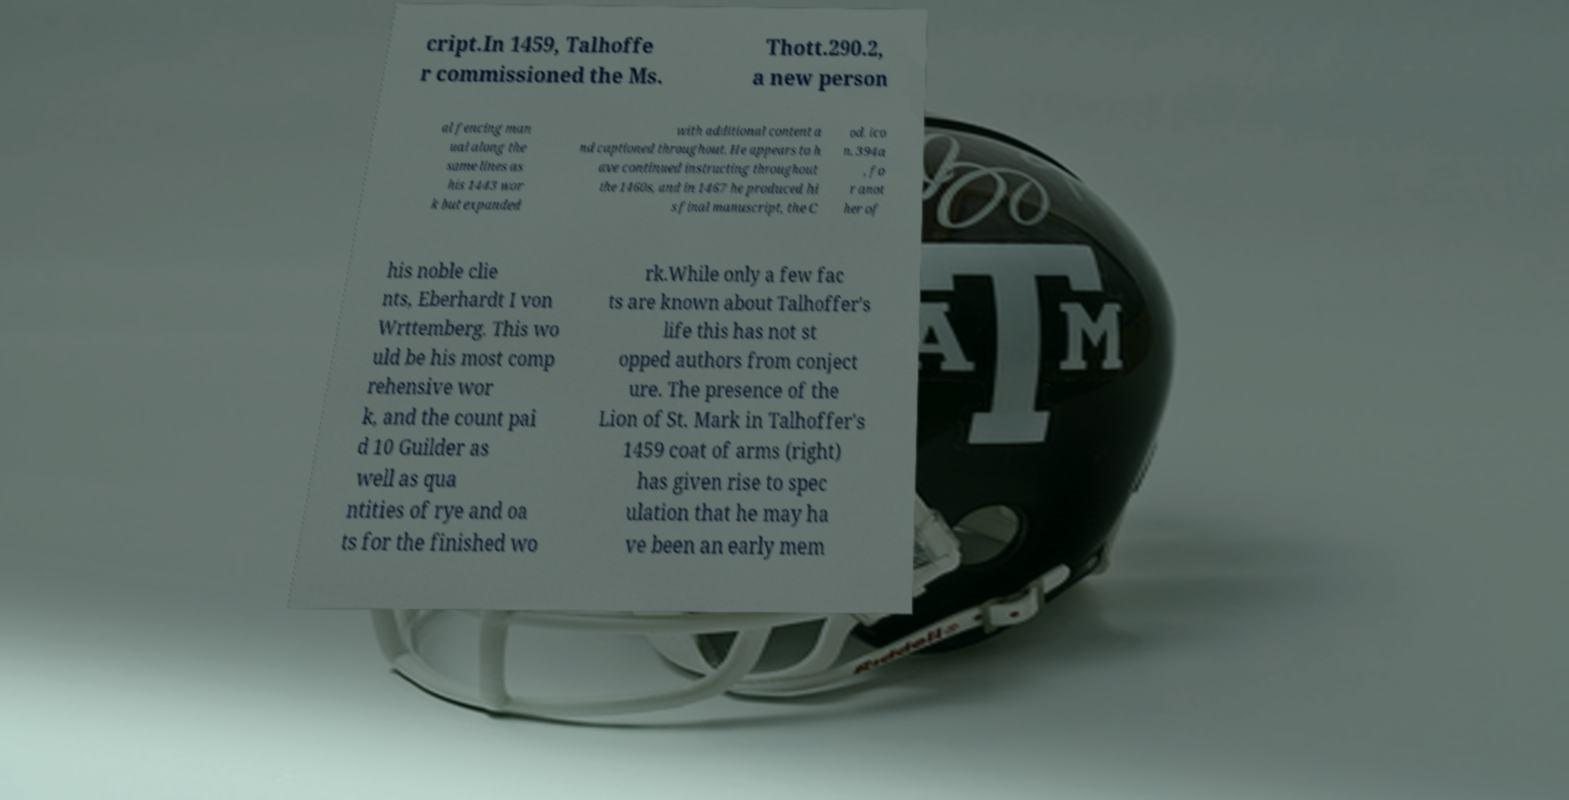Can you read and provide the text displayed in the image?This photo seems to have some interesting text. Can you extract and type it out for me? cript.In 1459, Talhoffe r commissioned the Ms. Thott.290.2, a new person al fencing man ual along the same lines as his 1443 wor k but expanded with additional content a nd captioned throughout. He appears to h ave continued instructing throughout the 1460s, and in 1467 he produced hi s final manuscript, the C od. ico n. 394a , fo r anot her of his noble clie nts, Eberhardt I von Wrttemberg. This wo uld be his most comp rehensive wor k, and the count pai d 10 Guilder as well as qua ntities of rye and oa ts for the finished wo rk.While only a few fac ts are known about Talhoffer's life this has not st opped authors from conject ure. The presence of the Lion of St. Mark in Talhoffer's 1459 coat of arms (right) has given rise to spec ulation that he may ha ve been an early mem 